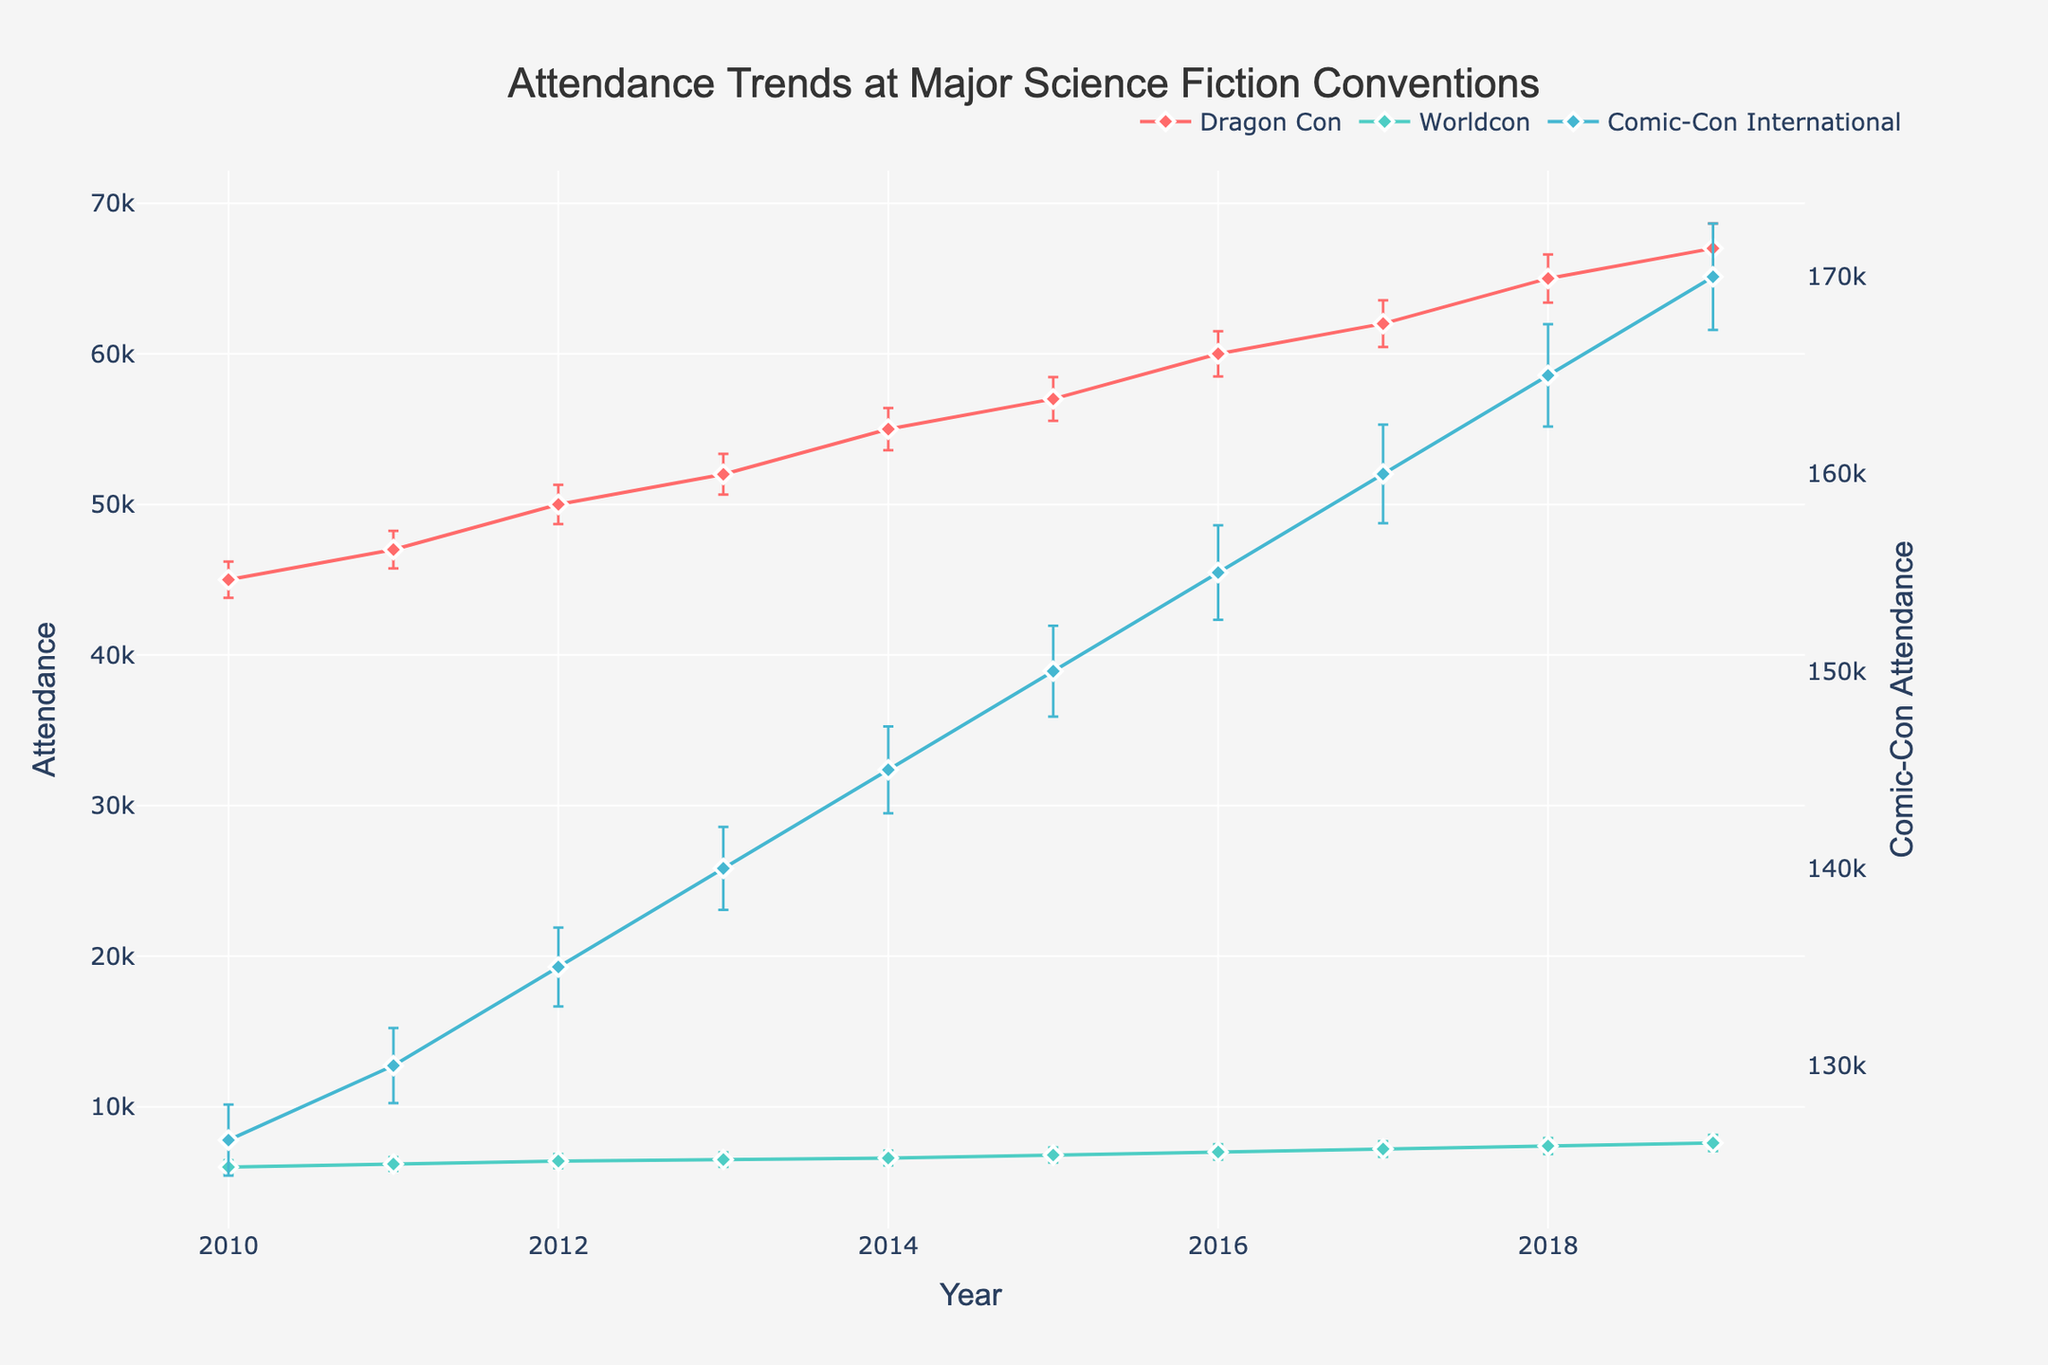What is the title of the figure? The title of the figure is usually displayed at the top center of the plot and provides a summary of the main topic of the figure. In this case, the title would explain what the figure is about.
Answer: Attendance Trends at Major Science Fiction Conventions How many conventions are tracked in the figure? By observing the legend or the plotted lines, one can count the number of unique conventions presented in the figure. Each convention is represented by different lines and markers.
Answer: Three What is the average attendance of Dragon Con in 2016? Locate the data point for the year 2016 along the x-axis and follow the marker corresponding to Dragon Con. The y-axis value at this point represents the average attendance.
Answer: 60,000 Which convention had the highest average attendance in 2019? Identify the year 2019 on the x-axis and compare the y-values of the data points for each convention. The convention with the highest y-value had the highest average attendance.
Answer: Comic-Con International Did Worldcon's attendance ever exceed 8,000 between 2010 and 2019? Examine the vertical axis values of Worldcon's data points across the years. Look for any data points that are above 8,000.
Answer: No What is the average growth in attendance for Comic-Con International from 2010 to 2019? Calculate the difference in attendance between 2019 and 2010 for Comic-Con International. Then, divide by the number of years to determine the average annual growth.
Answer: (170,000 - 126,221) / (2019 - 2010) = 4,876.5 What is the trend in Dragon Con's attendance from 2010 to 2019? Observe the line plot for Dragon Con to determine if the attendance generally increases, decreases, or remains stable over this period.
Answer: Increasing Between which years did Dragon Con see the largest increase in average attendance? Compute the differences in average attendance for Dragon Con between consecutive years and find the maximum value.
Answer: 2015 to 2016 How does the variability in Comic-Con International's attendance compare to Worldcon's? Assess the length of the error bars for both conventions. Longer error bars indicate greater variability. Compare these for Comic-Con International and Worldcon.
Answer: Comic-Con International has greater variability What is the primary difference in the axes between the two conventions' attendance data plots? Examine the y-axes labels and scales for conventions plotted on primary and secondary y-axes. Identify what distinguishes the two y-axes.
Answer: Primary y-axis represents Dragon Con and Worldcon, secondary y-axis represents Comic-Con International 